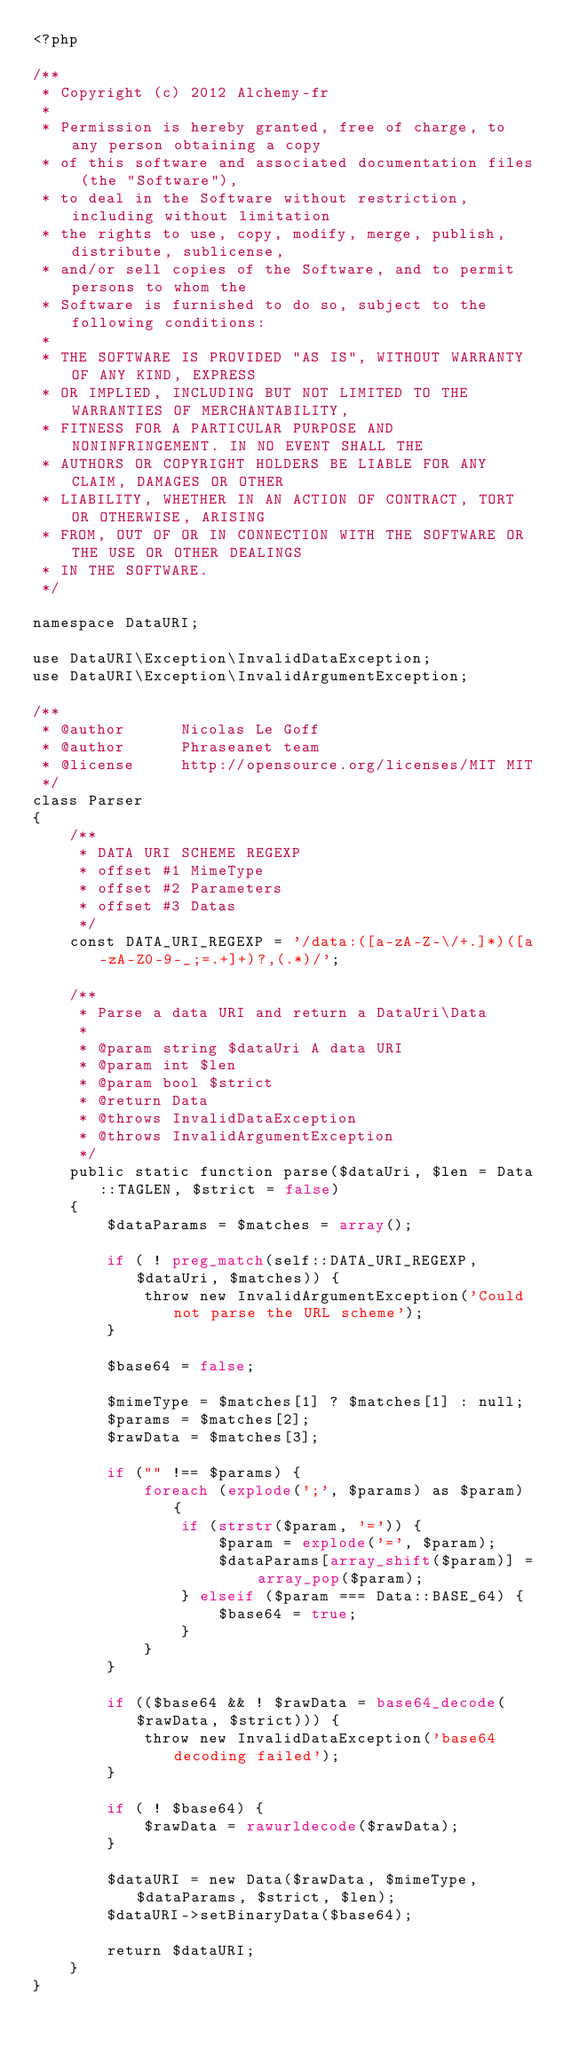Convert code to text. <code><loc_0><loc_0><loc_500><loc_500><_PHP_><?php

/**
 * Copyright (c) 2012 Alchemy-fr
 *
 * Permission is hereby granted, free of charge, to any person obtaining a copy
 * of this software and associated documentation files (the "Software"),
 * to deal in the Software without restriction, including without limitation
 * the rights to use, copy, modify, merge, publish, distribute, sublicense,
 * and/or sell copies of the Software, and to permit persons to whom the
 * Software is furnished to do so, subject to the following conditions:
 *
 * THE SOFTWARE IS PROVIDED "AS IS", WITHOUT WARRANTY OF ANY KIND, EXPRESS
 * OR IMPLIED, INCLUDING BUT NOT LIMITED TO THE WARRANTIES OF MERCHANTABILITY,
 * FITNESS FOR A PARTICULAR PURPOSE AND NONINFRINGEMENT. IN NO EVENT SHALL THE
 * AUTHORS OR COPYRIGHT HOLDERS BE LIABLE FOR ANY CLAIM, DAMAGES OR OTHER
 * LIABILITY, WHETHER IN AN ACTION OF CONTRACT, TORT OR OTHERWISE, ARISING
 * FROM, OUT OF OR IN CONNECTION WITH THE SOFTWARE OR THE USE OR OTHER DEALINGS
 * IN THE SOFTWARE.
 */

namespace DataURI;

use DataURI\Exception\InvalidDataException;
use DataURI\Exception\InvalidArgumentException;

/**
 * @author      Nicolas Le Goff
 * @author      Phraseanet team
 * @license     http://opensource.org/licenses/MIT MIT
 */
class Parser
{
    /**
     * DATA URI SCHEME REGEXP
     * offset #1 MimeType
     * offset #2 Parameters
     * offset #3 Datas
     */
    const DATA_URI_REGEXP = '/data:([a-zA-Z-\/+.]*)([a-zA-Z0-9-_;=.+]+)?,(.*)/';

    /**
     * Parse a data URI and return a DataUri\Data
     *
     * @param string $dataUri A data URI
     * @param int $len
     * @param bool $strict
     * @return Data
     * @throws InvalidDataException
     * @throws InvalidArgumentException
     */
    public static function parse($dataUri, $len = Data::TAGLEN, $strict = false)
    {
        $dataParams = $matches = array();

        if ( ! preg_match(self::DATA_URI_REGEXP, $dataUri, $matches)) {
            throw new InvalidArgumentException('Could not parse the URL scheme');
        }

        $base64 = false;

        $mimeType = $matches[1] ? $matches[1] : null;
        $params = $matches[2];
        $rawData = $matches[3];

        if ("" !== $params) {
            foreach (explode(';', $params) as $param) {
                if (strstr($param, '=')) {
                    $param = explode('=', $param);
                    $dataParams[array_shift($param)] = array_pop($param);
                } elseif ($param === Data::BASE_64) {
                    $base64 = true;
                }
            }
        }

        if (($base64 && ! $rawData = base64_decode($rawData, $strict))) {
            throw new InvalidDataException('base64 decoding failed');
        }

        if ( ! $base64) {
            $rawData = rawurldecode($rawData);
        }

        $dataURI = new Data($rawData, $mimeType, $dataParams, $strict, $len);
        $dataURI->setBinaryData($base64);

        return $dataURI;
    }
}
</code> 